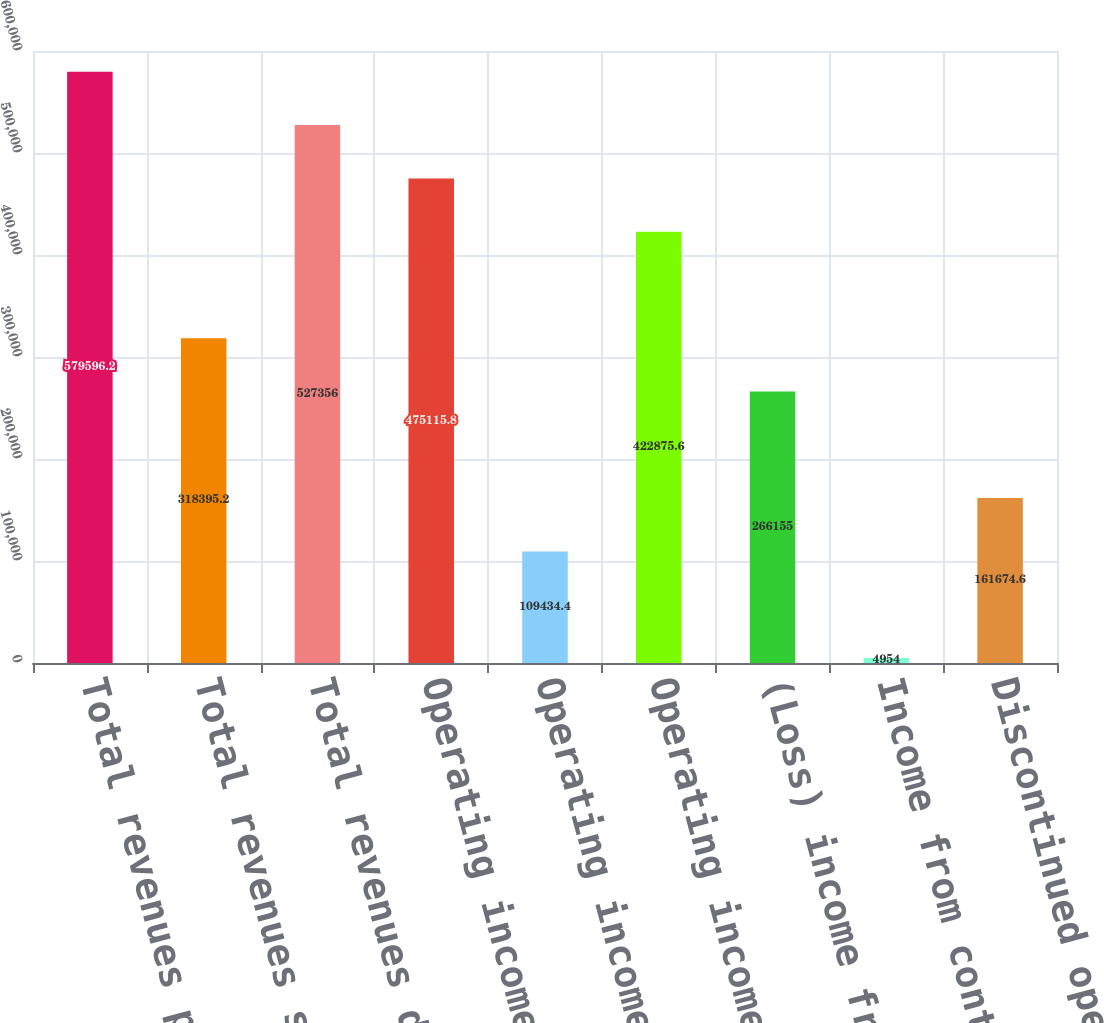Convert chart. <chart><loc_0><loc_0><loc_500><loc_500><bar_chart><fcel>Total revenues previously<fcel>Total revenues subsequently<fcel>Total revenues disclosed in<fcel>Operating income previously<fcel>Operating income subsequently<fcel>Operating income disclosed in<fcel>(Loss) income from continuing<fcel>Income from continuing<fcel>Discontinued operations net<nl><fcel>579596<fcel>318395<fcel>527356<fcel>475116<fcel>109434<fcel>422876<fcel>266155<fcel>4954<fcel>161675<nl></chart> 